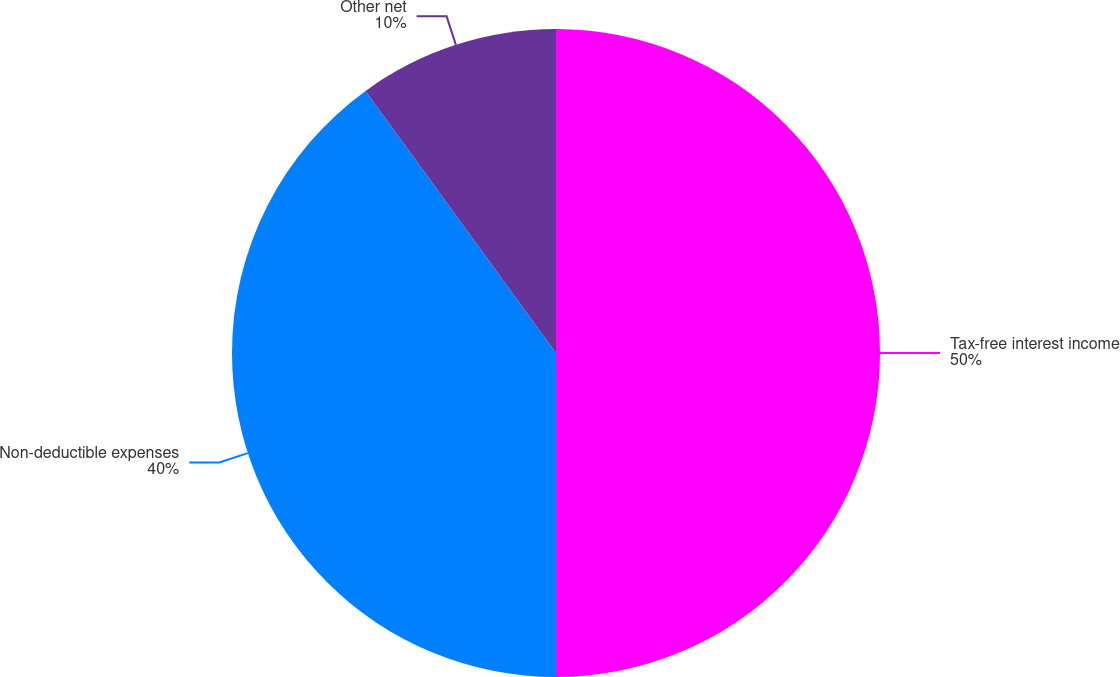<chart> <loc_0><loc_0><loc_500><loc_500><pie_chart><fcel>Tax-free interest income<fcel>Non-deductible expenses<fcel>Other net<nl><fcel>50.0%<fcel>40.0%<fcel>10.0%<nl></chart> 